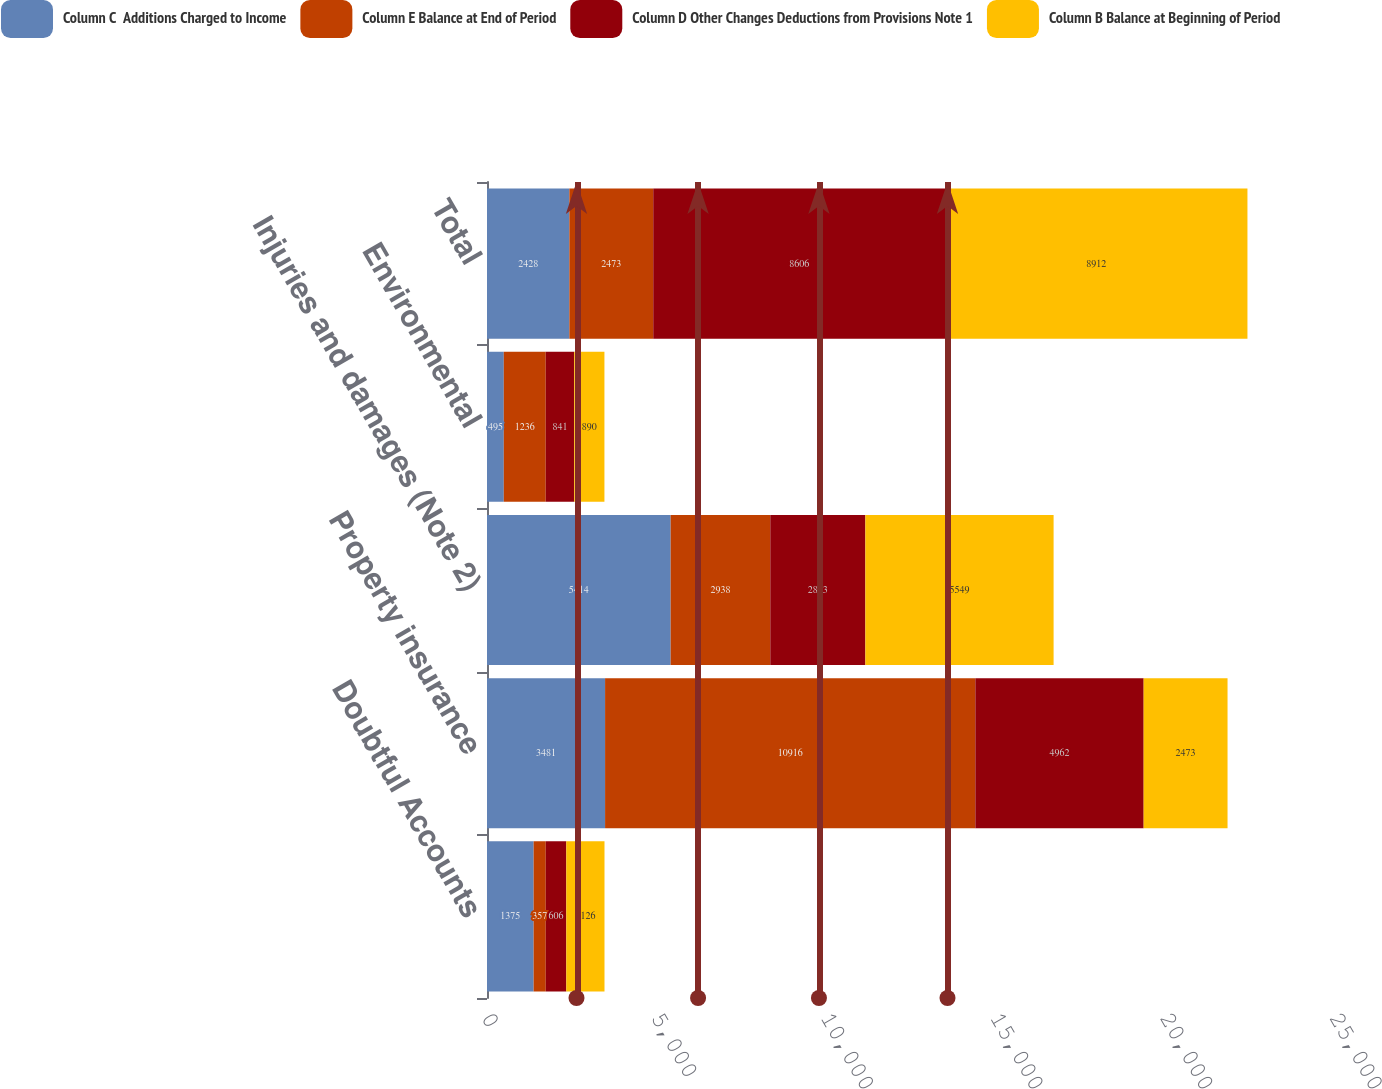<chart> <loc_0><loc_0><loc_500><loc_500><stacked_bar_chart><ecel><fcel>Doubtful Accounts<fcel>Property insurance<fcel>Injuries and damages (Note 2)<fcel>Environmental<fcel>Total<nl><fcel>Column C  Additions Charged to Income<fcel>1375<fcel>3481<fcel>5414<fcel>495<fcel>2428<nl><fcel>Column E Balance at End of Period<fcel>357<fcel>10916<fcel>2938<fcel>1236<fcel>2473<nl><fcel>Column D Other Changes Deductions from Provisions Note 1<fcel>606<fcel>4962<fcel>2803<fcel>841<fcel>8606<nl><fcel>Column B Balance at Beginning of Period<fcel>1126<fcel>2473<fcel>5549<fcel>890<fcel>8912<nl></chart> 